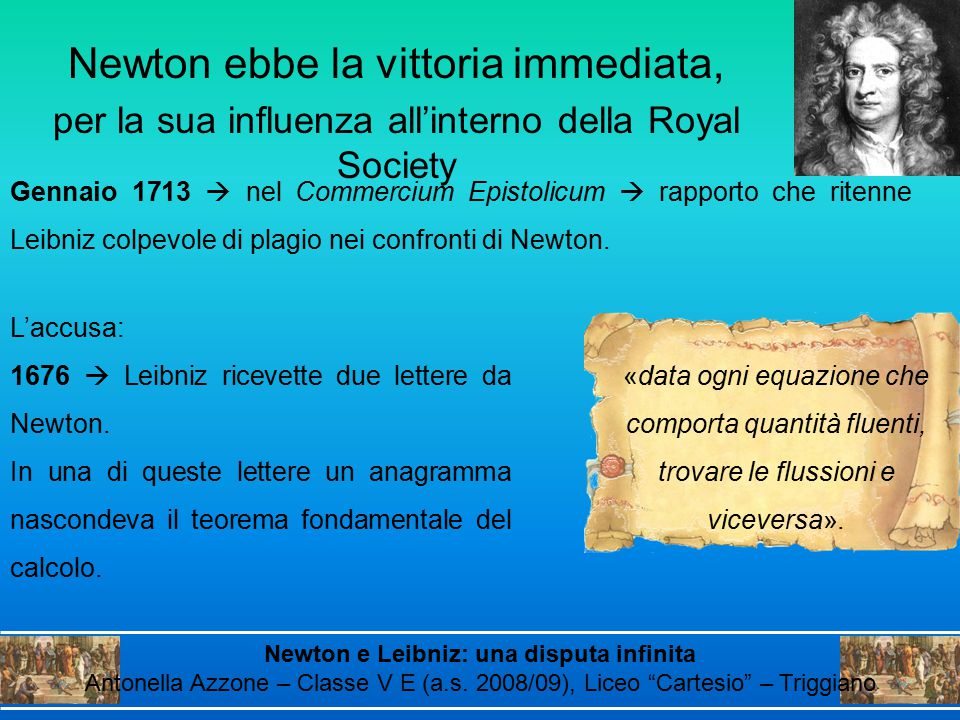Could you delve into the impact of Newton's influence on the Royal Society as indicated in the text? Newton's influence on the Royal Society was pivotal, especially during the height of his dispute with Leibniz. In January 1713, as noted in the 'Commercium Epistolicum,' Newton's standing within the Society allowed him to sway opinions and formally accuse Leibniz of plagiarizing his work on calculus. The Royal Society, being a premier institution of scientific inquiry in the 18th century, played a crucial role in shaping the scientific discourse. Newton’s power within the Society not only helped him secure immediate victory in the intellectual dispute but also ensured that his version of the events became the accepted narrative for a long time. This influence underscored the significant interplay between personal power dynamics and scientific recognition in historical contexts. What were the broader implications of this dispute on the development of mathematics and science? The Newton-Leibniz dispute over the invention of calculus had far-reaching implications for the field of mathematics and the broader scientific community. It highlighted the necessity for clearer communication and documentation of discoveries to avoid conflicts over intellectual property. This feud also intensified the competition between British and Continental mathematicians, leading to a period of prolific mathematical research and development. Both Newton's and Leibniz's notations and methodologies for calculus persisted and evolved, eventually becoming foundational principles in mathematics. The debate also emphasized the importance of formal scientific bodies, like the Royal Society, in mediating intellectual disputes and advancing scientific knowledge collectively. Consequently, this historical conflict spurred a more rigorous approach to scientific inquiry and collaboration, fostering an environment where diverse mathematical innovations could flourish. 